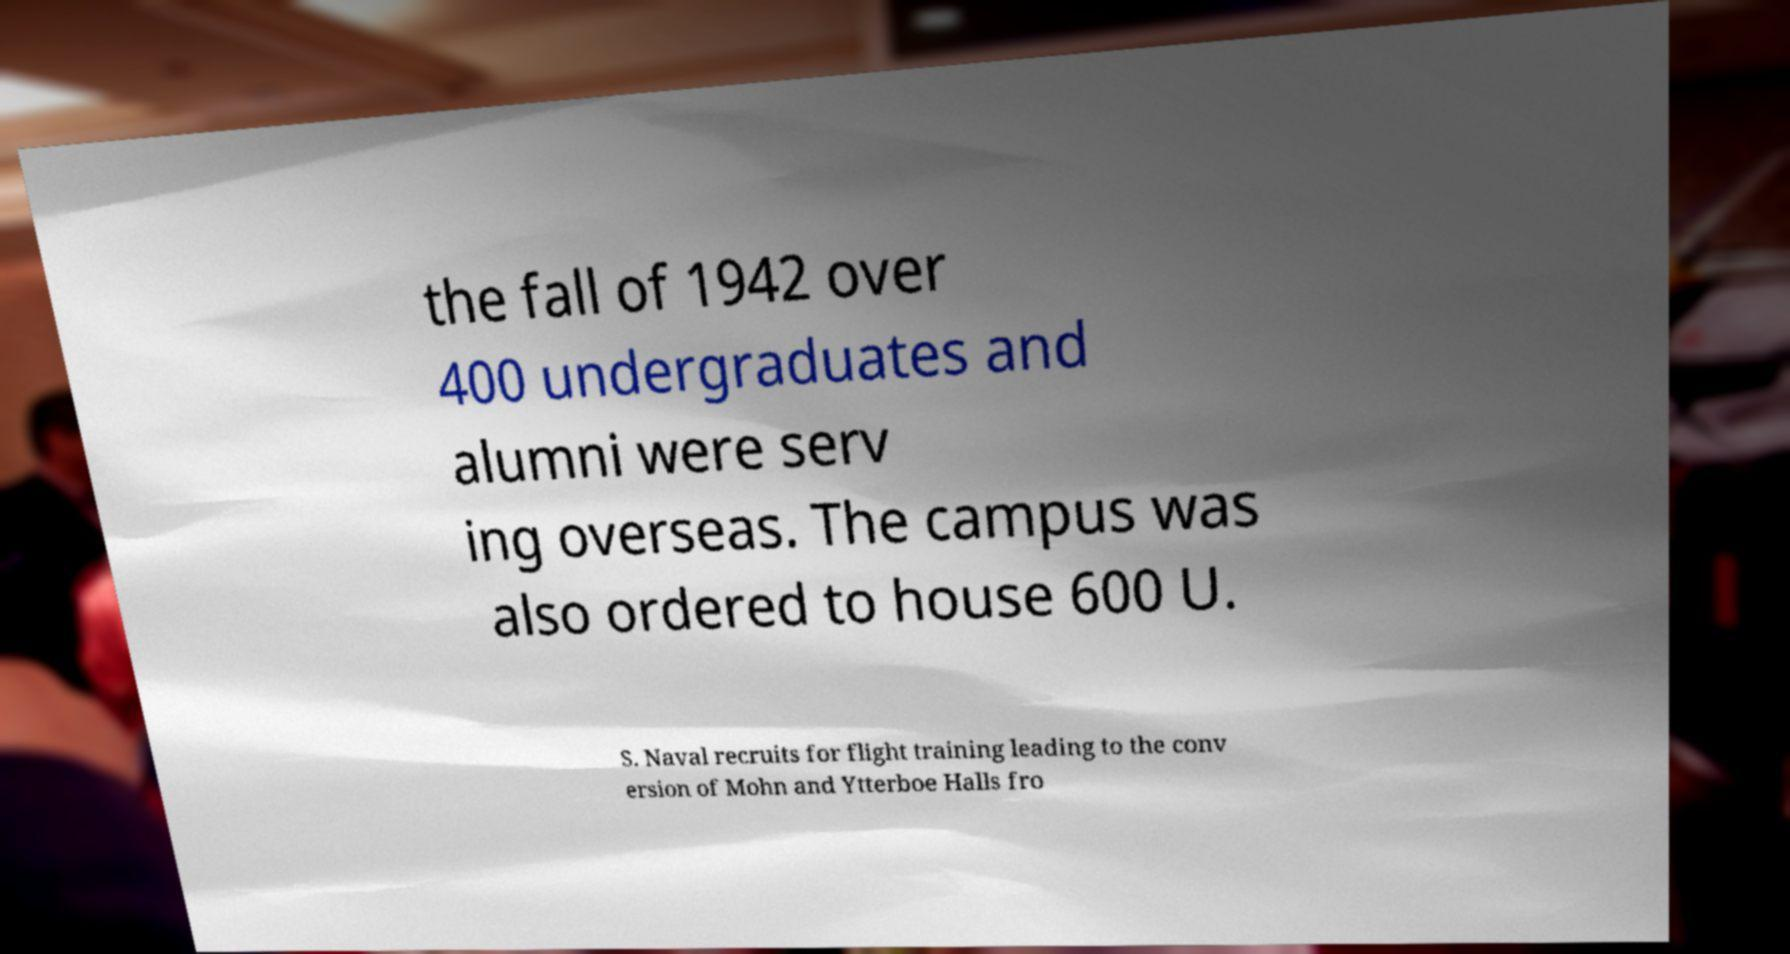Can you accurately transcribe the text from the provided image for me? the fall of 1942 over 400 undergraduates and alumni were serv ing overseas. The campus was also ordered to house 600 U. S. Naval recruits for flight training leading to the conv ersion of Mohn and Ytterboe Halls fro 